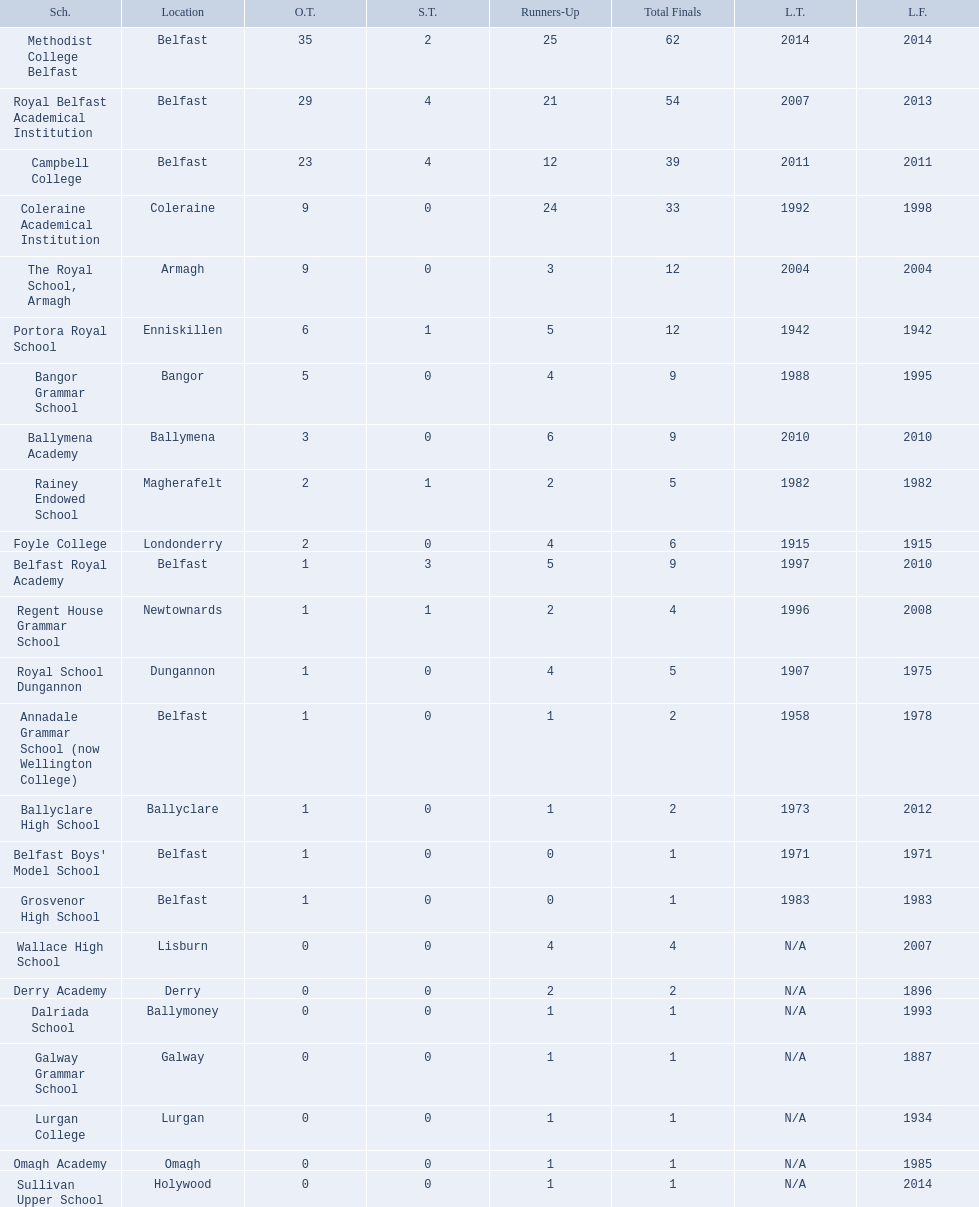How many outright titles does coleraine academical institution have? 9. What other school has this amount of outright titles The Royal School, Armagh. 